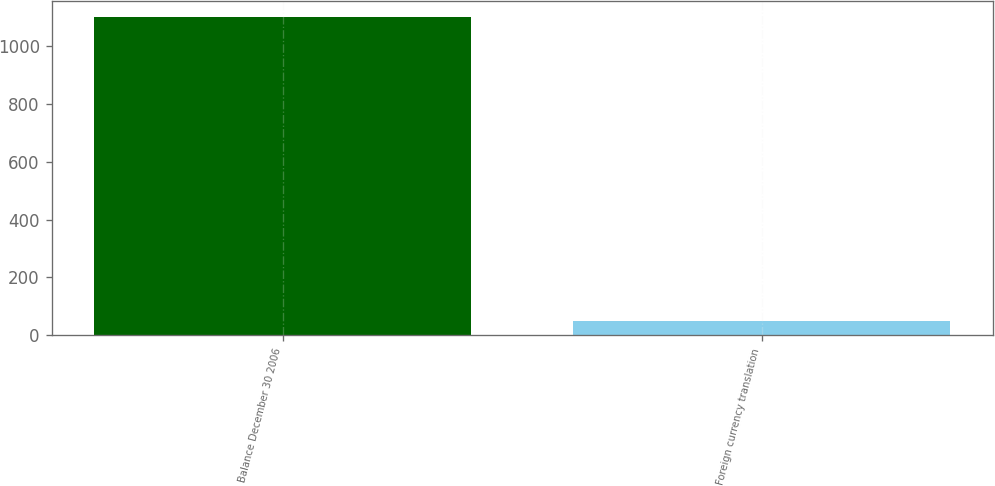Convert chart. <chart><loc_0><loc_0><loc_500><loc_500><bar_chart><fcel>Balance December 30 2006<fcel>Foreign currency translation<nl><fcel>1100.2<fcel>49.7<nl></chart> 